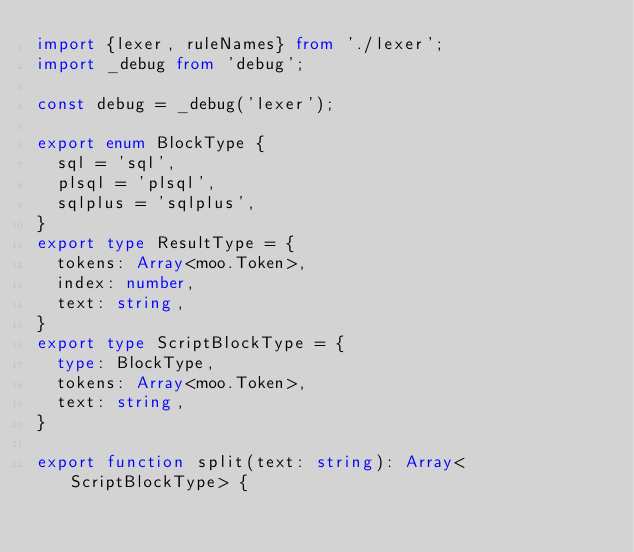<code> <loc_0><loc_0><loc_500><loc_500><_TypeScript_>import {lexer, ruleNames} from './lexer';
import _debug from 'debug';

const debug = _debug('lexer');

export enum BlockType {
	sql = 'sql',
	plsql = 'plsql',
	sqlplus = 'sqlplus',
}
export type ResultType = {
	tokens: Array<moo.Token>,
	index: number,
	text: string,
}
export type ScriptBlockType = {
	type: BlockType,
	tokens: Array<moo.Token>,
	text: string,
}

export function split(text: string): Array<ScriptBlockType> {</code> 